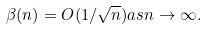<formula> <loc_0><loc_0><loc_500><loc_500>\beta ( n ) = O ( 1 / \sqrt { n } ) a s n \rightarrow \infty .</formula> 